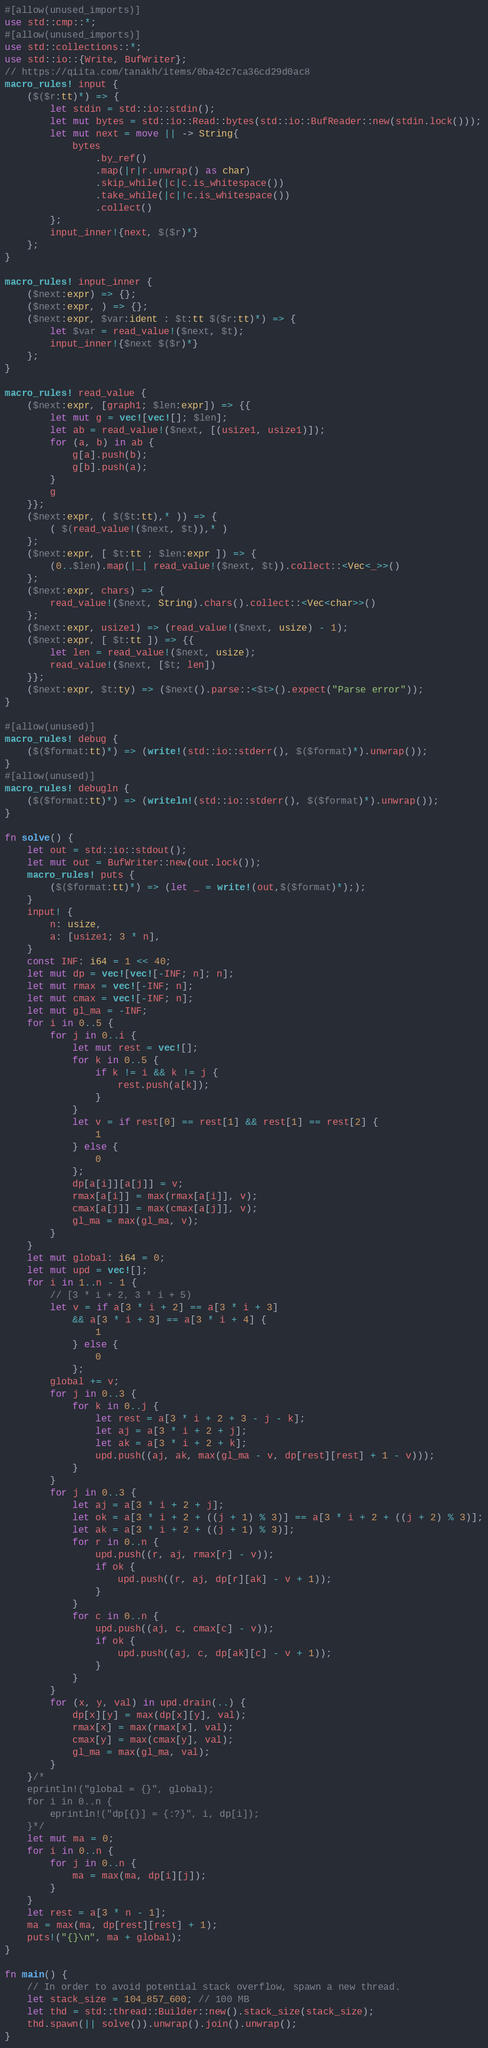<code> <loc_0><loc_0><loc_500><loc_500><_Rust_>#[allow(unused_imports)]
use std::cmp::*;
#[allow(unused_imports)]
use std::collections::*;
use std::io::{Write, BufWriter};
// https://qiita.com/tanakh/items/0ba42c7ca36cd29d0ac8
macro_rules! input {
    ($($r:tt)*) => {
        let stdin = std::io::stdin();
        let mut bytes = std::io::Read::bytes(std::io::BufReader::new(stdin.lock()));
        let mut next = move || -> String{
            bytes
                .by_ref()
                .map(|r|r.unwrap() as char)
                .skip_while(|c|c.is_whitespace())
                .take_while(|c|!c.is_whitespace())
                .collect()
        };
        input_inner!{next, $($r)*}
    };
}

macro_rules! input_inner {
    ($next:expr) => {};
    ($next:expr, ) => {};
    ($next:expr, $var:ident : $t:tt $($r:tt)*) => {
        let $var = read_value!($next, $t);
        input_inner!{$next $($r)*}
    };
}

macro_rules! read_value {
    ($next:expr, [graph1; $len:expr]) => {{
        let mut g = vec![vec![]; $len];
        let ab = read_value!($next, [(usize1, usize1)]);
        for (a, b) in ab {
            g[a].push(b);
            g[b].push(a);
        }
        g
    }};
    ($next:expr, ( $($t:tt),* )) => {
        ( $(read_value!($next, $t)),* )
    };
    ($next:expr, [ $t:tt ; $len:expr ]) => {
        (0..$len).map(|_| read_value!($next, $t)).collect::<Vec<_>>()
    };
    ($next:expr, chars) => {
        read_value!($next, String).chars().collect::<Vec<char>>()
    };
    ($next:expr, usize1) => (read_value!($next, usize) - 1);
    ($next:expr, [ $t:tt ]) => {{
        let len = read_value!($next, usize);
        read_value!($next, [$t; len])
    }};
    ($next:expr, $t:ty) => ($next().parse::<$t>().expect("Parse error"));
}

#[allow(unused)]
macro_rules! debug {
    ($($format:tt)*) => (write!(std::io::stderr(), $($format)*).unwrap());
}
#[allow(unused)]
macro_rules! debugln {
    ($($format:tt)*) => (writeln!(std::io::stderr(), $($format)*).unwrap());
}

fn solve() {
    let out = std::io::stdout();
    let mut out = BufWriter::new(out.lock());
    macro_rules! puts {
        ($($format:tt)*) => (let _ = write!(out,$($format)*););
    }
    input! {
        n: usize,
        a: [usize1; 3 * n],
    }
    const INF: i64 = 1 << 40;
    let mut dp = vec![vec![-INF; n]; n];
    let mut rmax = vec![-INF; n];
    let mut cmax = vec![-INF; n];
    let mut gl_ma = -INF;
    for i in 0..5 {
        for j in 0..i {
            let mut rest = vec![];
            for k in 0..5 {
                if k != i && k != j {
                    rest.push(a[k]);
                }
            }
            let v = if rest[0] == rest[1] && rest[1] == rest[2] {
                1
            } else {
                0
            };
            dp[a[i]][a[j]] = v;
            rmax[a[i]] = max(rmax[a[i]], v);
            cmax[a[j]] = max(cmax[a[j]], v);
            gl_ma = max(gl_ma, v);
        }
    }
    let mut global: i64 = 0;
    let mut upd = vec![];
    for i in 1..n - 1 {
        // [3 * i + 2, 3 * i + 5)
        let v = if a[3 * i + 2] == a[3 * i + 3]
            && a[3 * i + 3] == a[3 * i + 4] {
                1
            } else {
                0
            };
        global += v;
        for j in 0..3 {
            for k in 0..j {
                let rest = a[3 * i + 2 + 3 - j - k];
                let aj = a[3 * i + 2 + j];
                let ak = a[3 * i + 2 + k];
                upd.push((aj, ak, max(gl_ma - v, dp[rest][rest] + 1 - v)));
            }
        }
        for j in 0..3 {
            let aj = a[3 * i + 2 + j];
            let ok = a[3 * i + 2 + ((j + 1) % 3)] == a[3 * i + 2 + ((j + 2) % 3)];
            let ak = a[3 * i + 2 + ((j + 1) % 3)];
            for r in 0..n {
                upd.push((r, aj, rmax[r] - v));
                if ok {
                    upd.push((r, aj, dp[r][ak] - v + 1));
                }
            }
            for c in 0..n {
                upd.push((aj, c, cmax[c] - v));
                if ok {
                    upd.push((aj, c, dp[ak][c] - v + 1));
                }
            }
        }
        for (x, y, val) in upd.drain(..) {
            dp[x][y] = max(dp[x][y], val);
            rmax[x] = max(rmax[x], val);
            cmax[y] = max(cmax[y], val);
            gl_ma = max(gl_ma, val);
        }
    }/*
    eprintln!("global = {}", global);
    for i in 0..n {
        eprintln!("dp[{}] = {:?}", i, dp[i]);
    }*/
    let mut ma = 0;
    for i in 0..n {
        for j in 0..n {
            ma = max(ma, dp[i][j]);
        }
    }
    let rest = a[3 * n - 1];
    ma = max(ma, dp[rest][rest] + 1);
    puts!("{}\n", ma + global);
}

fn main() {
    // In order to avoid potential stack overflow, spawn a new thread.
    let stack_size = 104_857_600; // 100 MB
    let thd = std::thread::Builder::new().stack_size(stack_size);
    thd.spawn(|| solve()).unwrap().join().unwrap();
}
</code> 